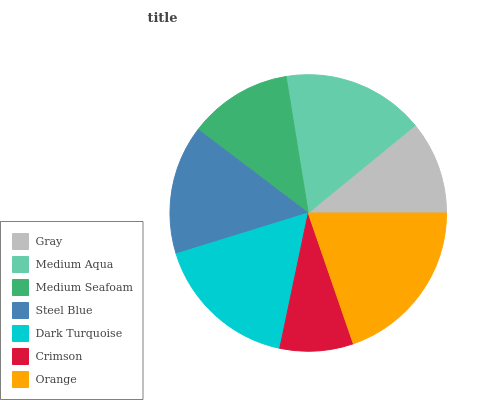Is Crimson the minimum?
Answer yes or no. Yes. Is Orange the maximum?
Answer yes or no. Yes. Is Medium Aqua the minimum?
Answer yes or no. No. Is Medium Aqua the maximum?
Answer yes or no. No. Is Medium Aqua greater than Gray?
Answer yes or no. Yes. Is Gray less than Medium Aqua?
Answer yes or no. Yes. Is Gray greater than Medium Aqua?
Answer yes or no. No. Is Medium Aqua less than Gray?
Answer yes or no. No. Is Steel Blue the high median?
Answer yes or no. Yes. Is Steel Blue the low median?
Answer yes or no. Yes. Is Medium Seafoam the high median?
Answer yes or no. No. Is Medium Seafoam the low median?
Answer yes or no. No. 